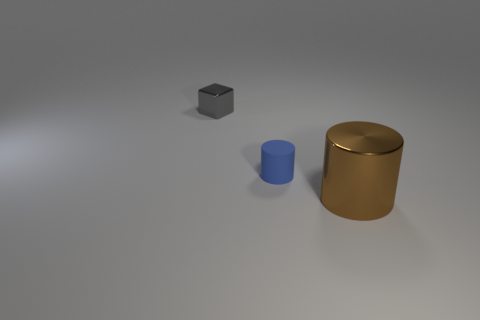Add 1 tiny gray metal things. How many objects exist? 4 Subtract 1 cubes. How many cubes are left? 0 Subtract all brown cylinders. How many cylinders are left? 1 Subtract all blocks. How many objects are left? 2 Subtract 1 gray cubes. How many objects are left? 2 Subtract all purple cylinders. Subtract all cyan spheres. How many cylinders are left? 2 Subtract all blue rubber blocks. Subtract all cylinders. How many objects are left? 1 Add 1 gray cubes. How many gray cubes are left? 2 Add 3 blue rubber cylinders. How many blue rubber cylinders exist? 4 